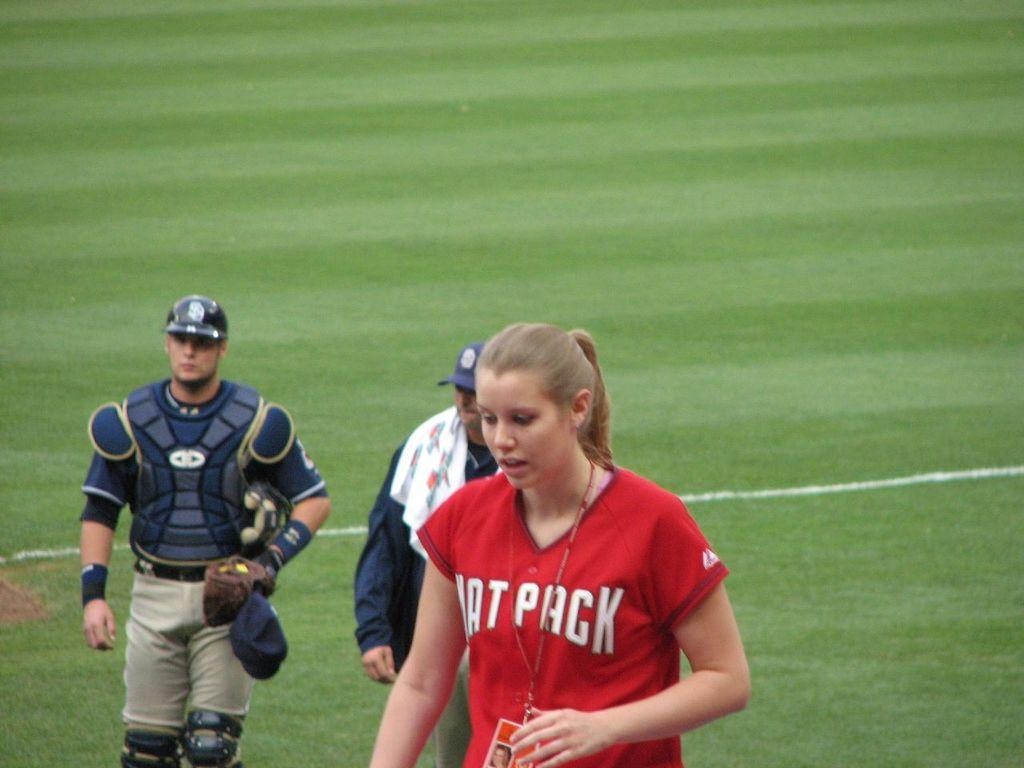<image>
Write a terse but informative summary of the picture. A girl is wearing a red shirt with "Pack" in white letters. 